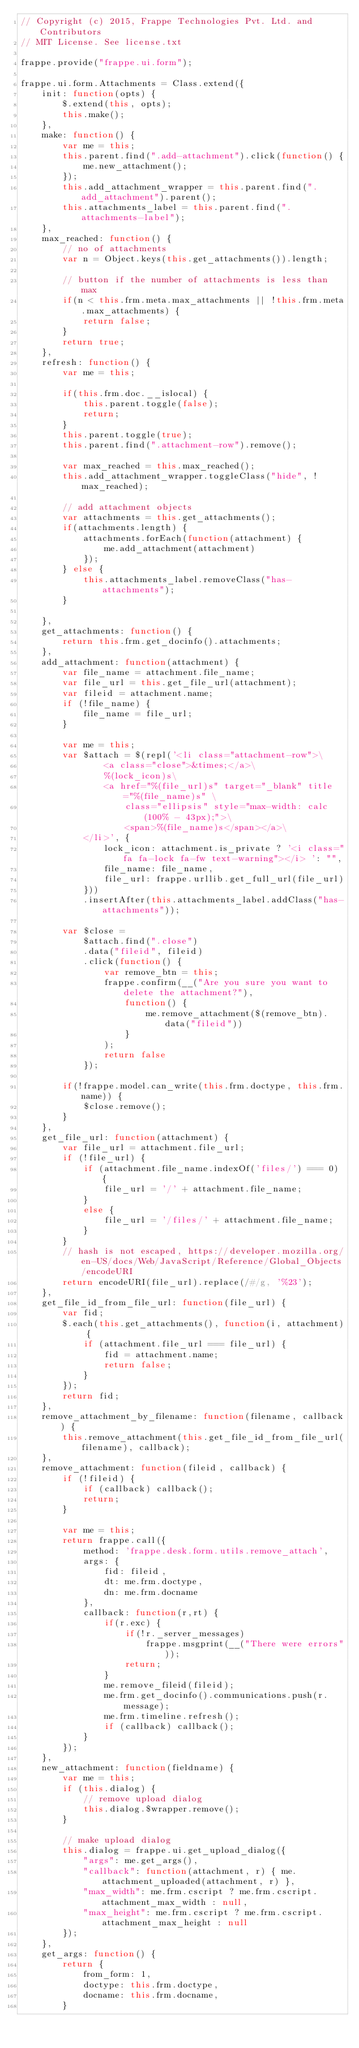Convert code to text. <code><loc_0><loc_0><loc_500><loc_500><_JavaScript_>// Copyright (c) 2015, Frappe Technologies Pvt. Ltd. and Contributors
// MIT License. See license.txt

frappe.provide("frappe.ui.form");

frappe.ui.form.Attachments = Class.extend({
	init: function(opts) {
		$.extend(this, opts);
		this.make();
	},
	make: function() {
		var me = this;
		this.parent.find(".add-attachment").click(function() {
			me.new_attachment();
		});
		this.add_attachment_wrapper = this.parent.find(".add_attachment").parent();
		this.attachments_label = this.parent.find(".attachments-label");
	},
	max_reached: function() {
		// no of attachments
		var n = Object.keys(this.get_attachments()).length;

		// button if the number of attachments is less than max
		if(n < this.frm.meta.max_attachments || !this.frm.meta.max_attachments) {
			return false;
		}
		return true;
	},
	refresh: function() {
		var me = this;

		if(this.frm.doc.__islocal) {
			this.parent.toggle(false);
			return;
		}
		this.parent.toggle(true);
		this.parent.find(".attachment-row").remove();

		var max_reached = this.max_reached();
		this.add_attachment_wrapper.toggleClass("hide", !max_reached);

		// add attachment objects
		var attachments = this.get_attachments();
		if(attachments.length) {
			attachments.forEach(function(attachment) {
				me.add_attachment(attachment)
			});
		} else {
			this.attachments_label.removeClass("has-attachments");
		}

	},
	get_attachments: function() {
		return this.frm.get_docinfo().attachments;
	},
	add_attachment: function(attachment) {
		var file_name = attachment.file_name;
		var file_url = this.get_file_url(attachment);
		var fileid = attachment.name;
		if (!file_name) {
			file_name = file_url;
		}

		var me = this;
		var $attach = $(repl('<li class="attachment-row">\
				<a class="close">&times;</a>\
				%(lock_icon)s\
				<a href="%(file_url)s" target="_blank" title="%(file_name)s" \
					class="ellipsis" style="max-width: calc(100% - 43px);">\
					<span>%(file_name)s</span></a>\
			</li>', {
				lock_icon: attachment.is_private ? '<i class="fa fa-lock fa-fw text-warning"></i> ': "",
				file_name: file_name,
				file_url: frappe.urllib.get_full_url(file_url)
			}))
			.insertAfter(this.attachments_label.addClass("has-attachments"));

		var $close =
			$attach.find(".close")
			.data("fileid", fileid)
			.click(function() {
				var remove_btn = this;
				frappe.confirm(__("Are you sure you want to delete the attachment?"),
					function() {
						me.remove_attachment($(remove_btn).data("fileid"))
					}
				);
				return false
			});

		if(!frappe.model.can_write(this.frm.doctype, this.frm.name)) {
			$close.remove();
		}
	},
	get_file_url: function(attachment) {
		var file_url = attachment.file_url;
		if (!file_url) {
			if (attachment.file_name.indexOf('files/') === 0) {
				file_url = '/' + attachment.file_name;
			}
			else {
				file_url = '/files/' + attachment.file_name;
			}
		}
		// hash is not escaped, https://developer.mozilla.org/en-US/docs/Web/JavaScript/Reference/Global_Objects/encodeURI
		return encodeURI(file_url).replace(/#/g, '%23');
	},
	get_file_id_from_file_url: function(file_url) {
		var fid;
		$.each(this.get_attachments(), function(i, attachment) {
			if (attachment.file_url === file_url) {
				fid = attachment.name;
				return false;
			}
		});
		return fid;
	},
	remove_attachment_by_filename: function(filename, callback) {
		this.remove_attachment(this.get_file_id_from_file_url(filename), callback);
	},
	remove_attachment: function(fileid, callback) {
		if (!fileid) {
			if (callback) callback();
			return;
		}

		var me = this;
		return frappe.call({
			method: 'frappe.desk.form.utils.remove_attach',
			args: {
				fid: fileid,
				dt: me.frm.doctype,
				dn: me.frm.docname
			},
			callback: function(r,rt) {
				if(r.exc) {
					if(!r._server_messages)
						frappe.msgprint(__("There were errors"));
					return;
				}
				me.remove_fileid(fileid);
				me.frm.get_docinfo().communications.push(r.message);
				me.frm.timeline.refresh();
				if (callback) callback();
			}
		});
	},
	new_attachment: function(fieldname) {
		var me = this;
		if (this.dialog) {
			// remove upload dialog
			this.dialog.$wrapper.remove();
		}

		// make upload dialog
		this.dialog = frappe.ui.get_upload_dialog({
			"args": me.get_args(),
			"callback": function(attachment, r) { me.attachment_uploaded(attachment, r) },
			"max_width": me.frm.cscript ? me.frm.cscript.attachment_max_width : null,
			"max_height": me.frm.cscript ? me.frm.cscript.attachment_max_height : null
		});
	},
	get_args: function() {
		return {
			from_form: 1,
			doctype: this.frm.doctype,
			docname: this.frm.docname,
		}</code> 